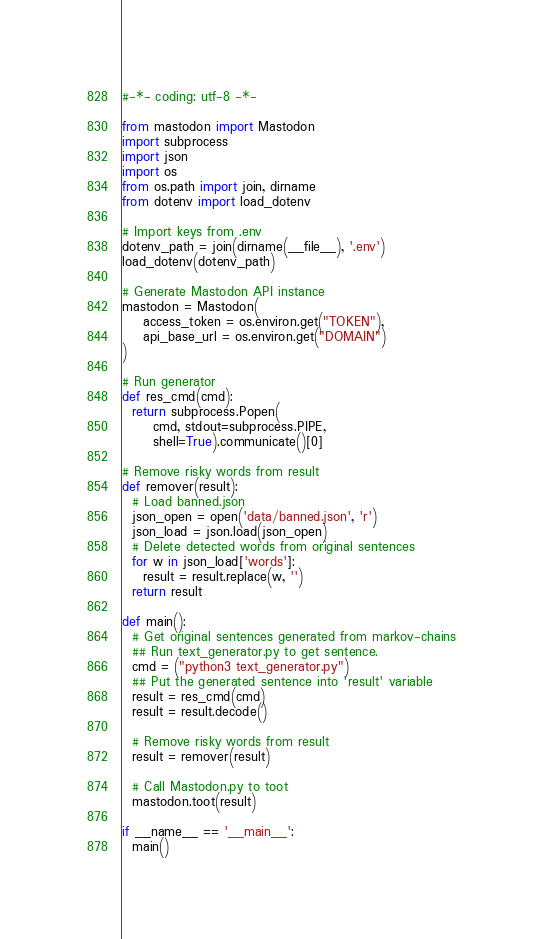<code> <loc_0><loc_0><loc_500><loc_500><_Python_>#-*- coding: utf-8 -*-

from mastodon import Mastodon
import subprocess
import json
import os
from os.path import join, dirname
from dotenv import load_dotenv

# Import keys from .env
dotenv_path = join(dirname(__file__), '.env')
load_dotenv(dotenv_path)

# Generate Mastodon API instance
mastodon = Mastodon(
    access_token = os.environ.get("TOKEN"),
    api_base_url = os.environ.get("DOMAIN")
)

# Run generator
def res_cmd(cmd):
  return subprocess.Popen(
      cmd, stdout=subprocess.PIPE,
      shell=True).communicate()[0]

# Remove risky words from result
def remover(result):
  # Load banned.json
  json_open = open('data/banned.json', 'r')
  json_load = json.load(json_open)
  # Delete detected words from original sentences
  for w in json_load['words']:
    result = result.replace(w, '')
  return result

def main():
  # Get original sentences generated from markov-chains
  ## Run text_generator.py to get sentence.
  cmd = ("python3 text_generator.py")
  ## Put the generated sentence into 'result' variable
  result = res_cmd(cmd)
  result = result.decode()

  # Remove risky words from result
  result = remover(result)

  # Call Mastodon.py to toot
  mastodon.toot(result)

if __name__ == '__main__':
  main()
</code> 